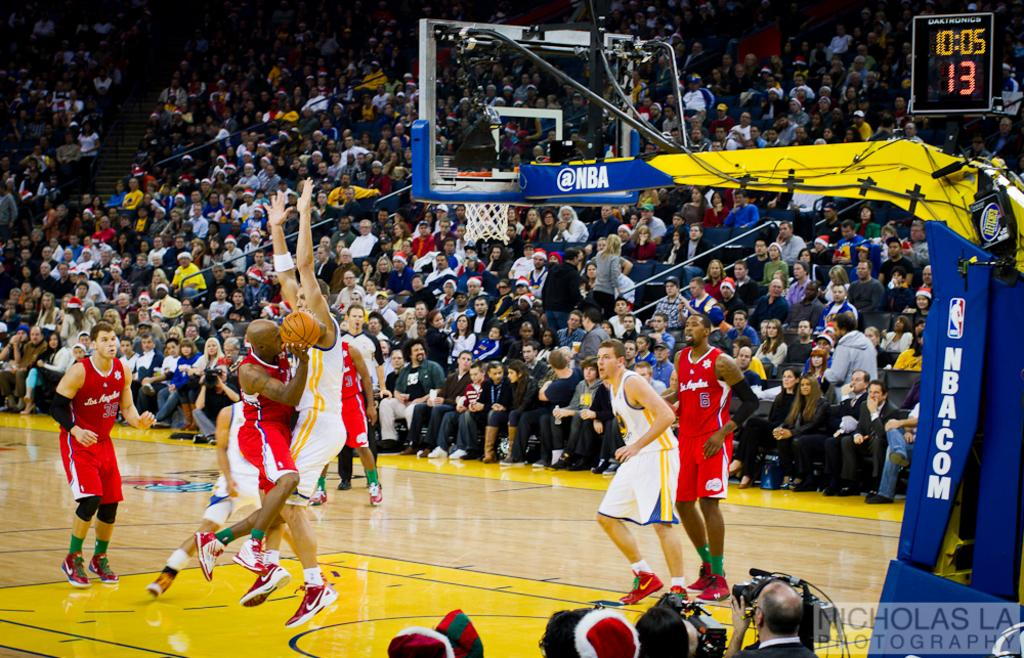<image>
Present a compact description of the photo's key features. A player for Los Angeles' basketball team attempts to take a shot. 